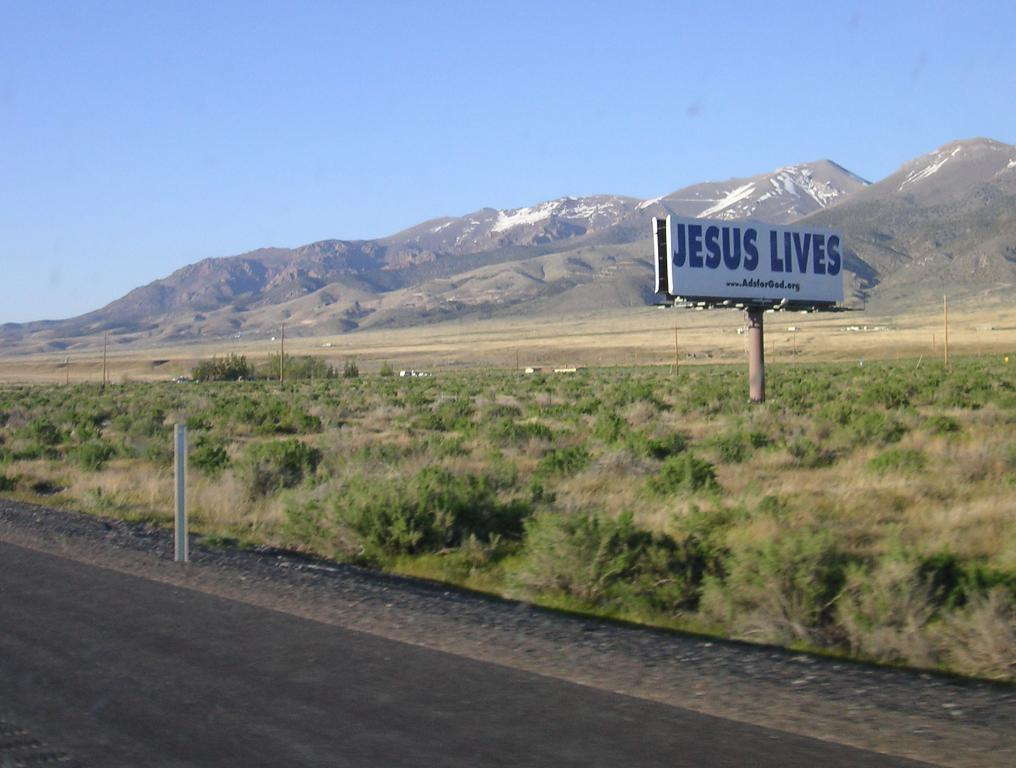<image>
Summarize the visual content of the image. a huge jesus lives sign is along the road in a mountainous area 